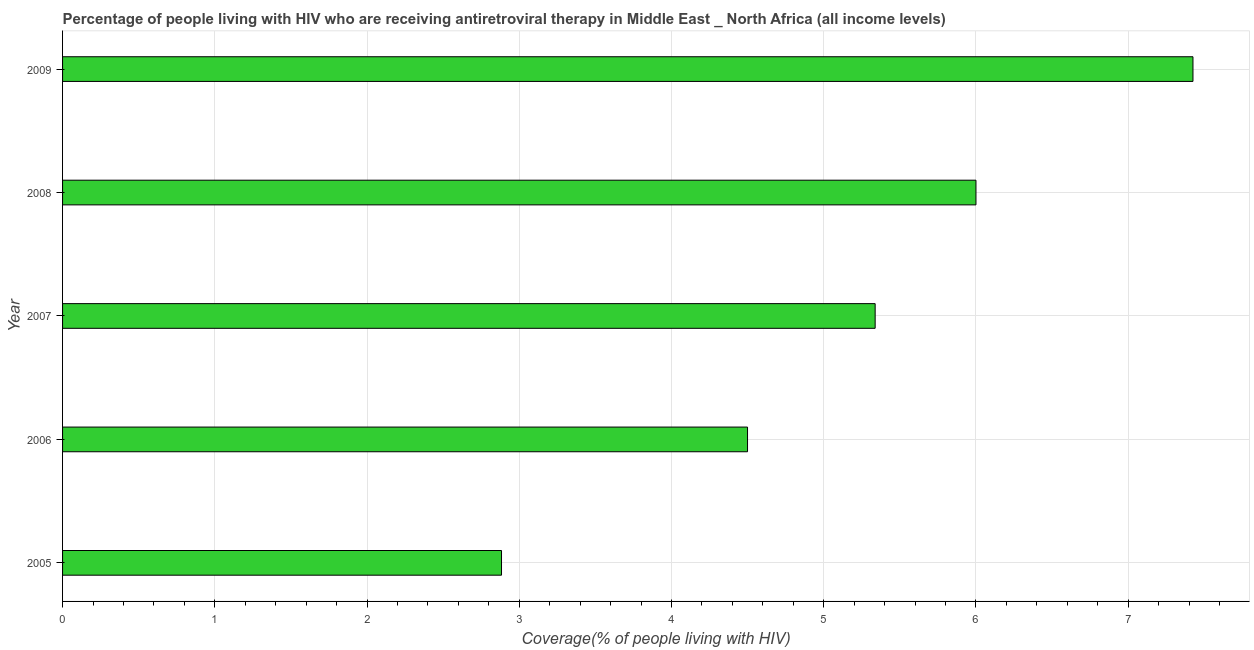Does the graph contain any zero values?
Your answer should be compact. No. What is the title of the graph?
Give a very brief answer. Percentage of people living with HIV who are receiving antiretroviral therapy in Middle East _ North Africa (all income levels). What is the label or title of the X-axis?
Your response must be concise. Coverage(% of people living with HIV). What is the label or title of the Y-axis?
Provide a short and direct response. Year. What is the antiretroviral therapy coverage in 2007?
Your answer should be compact. 5.34. Across all years, what is the maximum antiretroviral therapy coverage?
Provide a succinct answer. 7.43. Across all years, what is the minimum antiretroviral therapy coverage?
Your response must be concise. 2.88. In which year was the antiretroviral therapy coverage minimum?
Offer a terse response. 2005. What is the sum of the antiretroviral therapy coverage?
Ensure brevity in your answer.  26.15. What is the difference between the antiretroviral therapy coverage in 2005 and 2007?
Your answer should be very brief. -2.45. What is the average antiretroviral therapy coverage per year?
Ensure brevity in your answer.  5.23. What is the median antiretroviral therapy coverage?
Give a very brief answer. 5.34. In how many years, is the antiretroviral therapy coverage greater than 3.8 %?
Provide a short and direct response. 4. What is the ratio of the antiretroviral therapy coverage in 2007 to that in 2009?
Ensure brevity in your answer.  0.72. Is the antiretroviral therapy coverage in 2006 less than that in 2007?
Make the answer very short. Yes. Is the difference between the antiretroviral therapy coverage in 2005 and 2008 greater than the difference between any two years?
Give a very brief answer. No. What is the difference between the highest and the second highest antiretroviral therapy coverage?
Give a very brief answer. 1.43. Is the sum of the antiretroviral therapy coverage in 2006 and 2007 greater than the maximum antiretroviral therapy coverage across all years?
Offer a terse response. Yes. What is the difference between the highest and the lowest antiretroviral therapy coverage?
Provide a succinct answer. 4.54. How many bars are there?
Your answer should be very brief. 5. Are all the bars in the graph horizontal?
Make the answer very short. Yes. What is the Coverage(% of people living with HIV) in 2005?
Provide a short and direct response. 2.88. What is the Coverage(% of people living with HIV) of 2006?
Provide a succinct answer. 4.5. What is the Coverage(% of people living with HIV) of 2007?
Your answer should be compact. 5.34. What is the Coverage(% of people living with HIV) in 2009?
Give a very brief answer. 7.43. What is the difference between the Coverage(% of people living with HIV) in 2005 and 2006?
Provide a short and direct response. -1.62. What is the difference between the Coverage(% of people living with HIV) in 2005 and 2007?
Give a very brief answer. -2.45. What is the difference between the Coverage(% of people living with HIV) in 2005 and 2008?
Provide a succinct answer. -3.12. What is the difference between the Coverage(% of people living with HIV) in 2005 and 2009?
Your answer should be compact. -4.54. What is the difference between the Coverage(% of people living with HIV) in 2006 and 2007?
Give a very brief answer. -0.84. What is the difference between the Coverage(% of people living with HIV) in 2006 and 2008?
Provide a succinct answer. -1.5. What is the difference between the Coverage(% of people living with HIV) in 2006 and 2009?
Provide a succinct answer. -2.93. What is the difference between the Coverage(% of people living with HIV) in 2007 and 2008?
Your answer should be compact. -0.66. What is the difference between the Coverage(% of people living with HIV) in 2007 and 2009?
Offer a very short reply. -2.09. What is the difference between the Coverage(% of people living with HIV) in 2008 and 2009?
Offer a very short reply. -1.43. What is the ratio of the Coverage(% of people living with HIV) in 2005 to that in 2006?
Your answer should be very brief. 0.64. What is the ratio of the Coverage(% of people living with HIV) in 2005 to that in 2007?
Keep it short and to the point. 0.54. What is the ratio of the Coverage(% of people living with HIV) in 2005 to that in 2008?
Offer a very short reply. 0.48. What is the ratio of the Coverage(% of people living with HIV) in 2005 to that in 2009?
Keep it short and to the point. 0.39. What is the ratio of the Coverage(% of people living with HIV) in 2006 to that in 2007?
Your response must be concise. 0.84. What is the ratio of the Coverage(% of people living with HIV) in 2006 to that in 2009?
Keep it short and to the point. 0.61. What is the ratio of the Coverage(% of people living with HIV) in 2007 to that in 2008?
Offer a very short reply. 0.89. What is the ratio of the Coverage(% of people living with HIV) in 2007 to that in 2009?
Your answer should be compact. 0.72. What is the ratio of the Coverage(% of people living with HIV) in 2008 to that in 2009?
Provide a succinct answer. 0.81. 